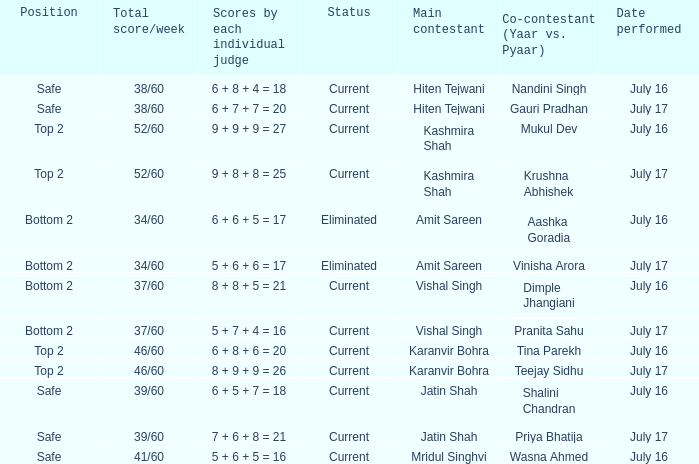What position did the team with the total score of 41/60 get? Safe. 